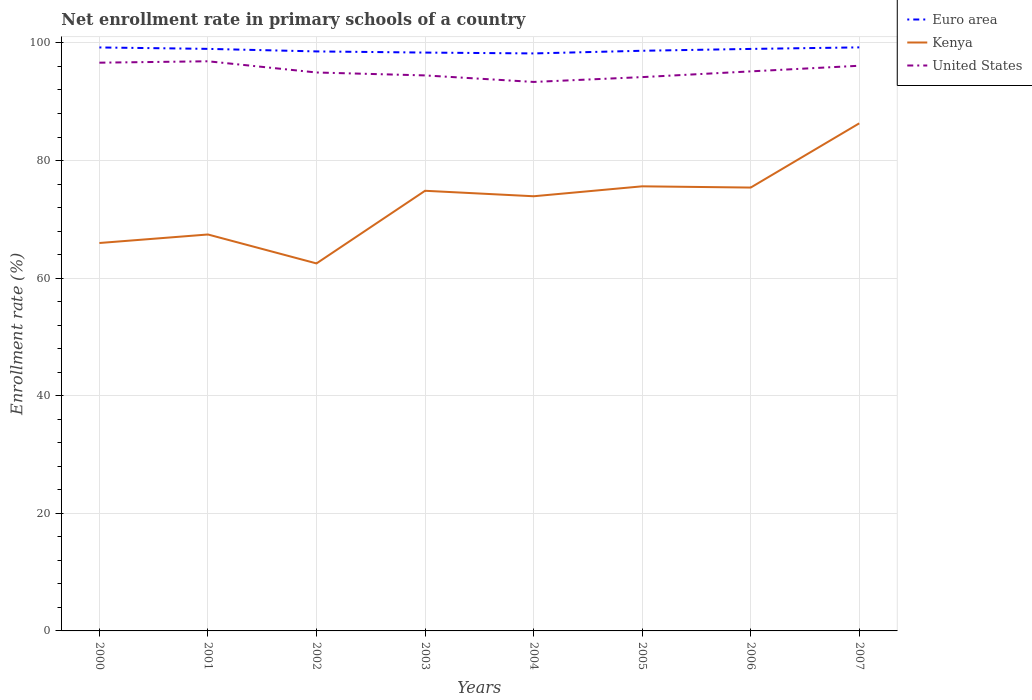How many different coloured lines are there?
Provide a succinct answer. 3. Does the line corresponding to Euro area intersect with the line corresponding to United States?
Ensure brevity in your answer.  No. Across all years, what is the maximum enrollment rate in primary schools in Euro area?
Give a very brief answer. 98.22. In which year was the enrollment rate in primary schools in United States maximum?
Give a very brief answer. 2004. What is the total enrollment rate in primary schools in United States in the graph?
Your answer should be very brief. 2.17. What is the difference between the highest and the second highest enrollment rate in primary schools in United States?
Provide a succinct answer. 3.51. Is the enrollment rate in primary schools in United States strictly greater than the enrollment rate in primary schools in Kenya over the years?
Give a very brief answer. No. How many years are there in the graph?
Keep it short and to the point. 8. What is the difference between two consecutive major ticks on the Y-axis?
Ensure brevity in your answer.  20. Does the graph contain grids?
Offer a terse response. Yes. Where does the legend appear in the graph?
Make the answer very short. Top right. What is the title of the graph?
Provide a short and direct response. Net enrollment rate in primary schools of a country. What is the label or title of the Y-axis?
Offer a very short reply. Enrollment rate (%). What is the Enrollment rate (%) of Euro area in 2000?
Your answer should be compact. 99.23. What is the Enrollment rate (%) of Kenya in 2000?
Your answer should be compact. 65.97. What is the Enrollment rate (%) of United States in 2000?
Your answer should be compact. 96.64. What is the Enrollment rate (%) in Euro area in 2001?
Give a very brief answer. 98.99. What is the Enrollment rate (%) in Kenya in 2001?
Provide a succinct answer. 67.42. What is the Enrollment rate (%) in United States in 2001?
Offer a terse response. 96.88. What is the Enrollment rate (%) in Euro area in 2002?
Give a very brief answer. 98.56. What is the Enrollment rate (%) in Kenya in 2002?
Your answer should be compact. 62.5. What is the Enrollment rate (%) of United States in 2002?
Your answer should be very brief. 94.97. What is the Enrollment rate (%) in Euro area in 2003?
Provide a short and direct response. 98.36. What is the Enrollment rate (%) in Kenya in 2003?
Ensure brevity in your answer.  74.85. What is the Enrollment rate (%) of United States in 2003?
Make the answer very short. 94.47. What is the Enrollment rate (%) of Euro area in 2004?
Ensure brevity in your answer.  98.22. What is the Enrollment rate (%) of Kenya in 2004?
Ensure brevity in your answer.  73.92. What is the Enrollment rate (%) in United States in 2004?
Ensure brevity in your answer.  93.36. What is the Enrollment rate (%) in Euro area in 2005?
Provide a succinct answer. 98.67. What is the Enrollment rate (%) of Kenya in 2005?
Your answer should be compact. 75.61. What is the Enrollment rate (%) in United States in 2005?
Provide a succinct answer. 94.19. What is the Enrollment rate (%) in Euro area in 2006?
Keep it short and to the point. 98.98. What is the Enrollment rate (%) in Kenya in 2006?
Give a very brief answer. 75.4. What is the Enrollment rate (%) in United States in 2006?
Provide a short and direct response. 95.16. What is the Enrollment rate (%) of Euro area in 2007?
Offer a terse response. 99.24. What is the Enrollment rate (%) in Kenya in 2007?
Offer a terse response. 86.33. What is the Enrollment rate (%) of United States in 2007?
Offer a terse response. 96.12. Across all years, what is the maximum Enrollment rate (%) in Euro area?
Keep it short and to the point. 99.24. Across all years, what is the maximum Enrollment rate (%) of Kenya?
Your response must be concise. 86.33. Across all years, what is the maximum Enrollment rate (%) of United States?
Your response must be concise. 96.88. Across all years, what is the minimum Enrollment rate (%) of Euro area?
Provide a short and direct response. 98.22. Across all years, what is the minimum Enrollment rate (%) in Kenya?
Keep it short and to the point. 62.5. Across all years, what is the minimum Enrollment rate (%) in United States?
Your answer should be compact. 93.36. What is the total Enrollment rate (%) of Euro area in the graph?
Keep it short and to the point. 790.24. What is the total Enrollment rate (%) of Kenya in the graph?
Your answer should be compact. 582.01. What is the total Enrollment rate (%) of United States in the graph?
Make the answer very short. 761.8. What is the difference between the Enrollment rate (%) in Euro area in 2000 and that in 2001?
Ensure brevity in your answer.  0.24. What is the difference between the Enrollment rate (%) of Kenya in 2000 and that in 2001?
Keep it short and to the point. -1.45. What is the difference between the Enrollment rate (%) of United States in 2000 and that in 2001?
Keep it short and to the point. -0.24. What is the difference between the Enrollment rate (%) of Euro area in 2000 and that in 2002?
Ensure brevity in your answer.  0.68. What is the difference between the Enrollment rate (%) of Kenya in 2000 and that in 2002?
Provide a short and direct response. 3.47. What is the difference between the Enrollment rate (%) of United States in 2000 and that in 2002?
Your answer should be very brief. 1.67. What is the difference between the Enrollment rate (%) in Euro area in 2000 and that in 2003?
Ensure brevity in your answer.  0.87. What is the difference between the Enrollment rate (%) of Kenya in 2000 and that in 2003?
Keep it short and to the point. -8.88. What is the difference between the Enrollment rate (%) of United States in 2000 and that in 2003?
Offer a terse response. 2.17. What is the difference between the Enrollment rate (%) in Euro area in 2000 and that in 2004?
Provide a short and direct response. 1.02. What is the difference between the Enrollment rate (%) in Kenya in 2000 and that in 2004?
Your response must be concise. -7.95. What is the difference between the Enrollment rate (%) in United States in 2000 and that in 2004?
Your answer should be very brief. 3.27. What is the difference between the Enrollment rate (%) in Euro area in 2000 and that in 2005?
Keep it short and to the point. 0.56. What is the difference between the Enrollment rate (%) in Kenya in 2000 and that in 2005?
Your answer should be very brief. -9.64. What is the difference between the Enrollment rate (%) in United States in 2000 and that in 2005?
Your answer should be very brief. 2.45. What is the difference between the Enrollment rate (%) in Euro area in 2000 and that in 2006?
Your response must be concise. 0.25. What is the difference between the Enrollment rate (%) in Kenya in 2000 and that in 2006?
Your answer should be compact. -9.43. What is the difference between the Enrollment rate (%) in United States in 2000 and that in 2006?
Offer a very short reply. 1.48. What is the difference between the Enrollment rate (%) in Euro area in 2000 and that in 2007?
Ensure brevity in your answer.  -0.01. What is the difference between the Enrollment rate (%) of Kenya in 2000 and that in 2007?
Provide a short and direct response. -20.35. What is the difference between the Enrollment rate (%) of United States in 2000 and that in 2007?
Make the answer very short. 0.52. What is the difference between the Enrollment rate (%) in Euro area in 2001 and that in 2002?
Provide a succinct answer. 0.43. What is the difference between the Enrollment rate (%) of Kenya in 2001 and that in 2002?
Provide a succinct answer. 4.92. What is the difference between the Enrollment rate (%) in United States in 2001 and that in 2002?
Your response must be concise. 1.91. What is the difference between the Enrollment rate (%) in Euro area in 2001 and that in 2003?
Provide a short and direct response. 0.63. What is the difference between the Enrollment rate (%) of Kenya in 2001 and that in 2003?
Your answer should be very brief. -7.43. What is the difference between the Enrollment rate (%) in United States in 2001 and that in 2003?
Provide a short and direct response. 2.4. What is the difference between the Enrollment rate (%) in Euro area in 2001 and that in 2004?
Keep it short and to the point. 0.77. What is the difference between the Enrollment rate (%) in Kenya in 2001 and that in 2004?
Ensure brevity in your answer.  -6.5. What is the difference between the Enrollment rate (%) in United States in 2001 and that in 2004?
Make the answer very short. 3.51. What is the difference between the Enrollment rate (%) of Euro area in 2001 and that in 2005?
Offer a terse response. 0.32. What is the difference between the Enrollment rate (%) in Kenya in 2001 and that in 2005?
Your answer should be compact. -8.19. What is the difference between the Enrollment rate (%) in United States in 2001 and that in 2005?
Offer a very short reply. 2.69. What is the difference between the Enrollment rate (%) of Euro area in 2001 and that in 2006?
Provide a succinct answer. 0.01. What is the difference between the Enrollment rate (%) of Kenya in 2001 and that in 2006?
Your answer should be very brief. -7.98. What is the difference between the Enrollment rate (%) in United States in 2001 and that in 2006?
Your answer should be very brief. 1.72. What is the difference between the Enrollment rate (%) of Euro area in 2001 and that in 2007?
Make the answer very short. -0.25. What is the difference between the Enrollment rate (%) of Kenya in 2001 and that in 2007?
Provide a short and direct response. -18.9. What is the difference between the Enrollment rate (%) in United States in 2001 and that in 2007?
Keep it short and to the point. 0.76. What is the difference between the Enrollment rate (%) of Euro area in 2002 and that in 2003?
Make the answer very short. 0.2. What is the difference between the Enrollment rate (%) of Kenya in 2002 and that in 2003?
Offer a very short reply. -12.35. What is the difference between the Enrollment rate (%) in United States in 2002 and that in 2003?
Your response must be concise. 0.5. What is the difference between the Enrollment rate (%) of Euro area in 2002 and that in 2004?
Provide a short and direct response. 0.34. What is the difference between the Enrollment rate (%) of Kenya in 2002 and that in 2004?
Your response must be concise. -11.42. What is the difference between the Enrollment rate (%) of United States in 2002 and that in 2004?
Offer a terse response. 1.61. What is the difference between the Enrollment rate (%) in Euro area in 2002 and that in 2005?
Keep it short and to the point. -0.11. What is the difference between the Enrollment rate (%) in Kenya in 2002 and that in 2005?
Offer a terse response. -13.11. What is the difference between the Enrollment rate (%) in United States in 2002 and that in 2005?
Your answer should be compact. 0.79. What is the difference between the Enrollment rate (%) of Euro area in 2002 and that in 2006?
Your response must be concise. -0.43. What is the difference between the Enrollment rate (%) of Kenya in 2002 and that in 2006?
Offer a very short reply. -12.9. What is the difference between the Enrollment rate (%) in United States in 2002 and that in 2006?
Your answer should be compact. -0.19. What is the difference between the Enrollment rate (%) in Euro area in 2002 and that in 2007?
Give a very brief answer. -0.69. What is the difference between the Enrollment rate (%) of Kenya in 2002 and that in 2007?
Keep it short and to the point. -23.82. What is the difference between the Enrollment rate (%) in United States in 2002 and that in 2007?
Ensure brevity in your answer.  -1.15. What is the difference between the Enrollment rate (%) of Euro area in 2003 and that in 2004?
Your answer should be very brief. 0.14. What is the difference between the Enrollment rate (%) in Kenya in 2003 and that in 2004?
Make the answer very short. 0.93. What is the difference between the Enrollment rate (%) in United States in 2003 and that in 2004?
Your answer should be compact. 1.11. What is the difference between the Enrollment rate (%) of Euro area in 2003 and that in 2005?
Offer a very short reply. -0.31. What is the difference between the Enrollment rate (%) of Kenya in 2003 and that in 2005?
Your response must be concise. -0.76. What is the difference between the Enrollment rate (%) in United States in 2003 and that in 2005?
Your answer should be very brief. 0.29. What is the difference between the Enrollment rate (%) in Euro area in 2003 and that in 2006?
Keep it short and to the point. -0.62. What is the difference between the Enrollment rate (%) of Kenya in 2003 and that in 2006?
Provide a succinct answer. -0.55. What is the difference between the Enrollment rate (%) in United States in 2003 and that in 2006?
Offer a terse response. -0.69. What is the difference between the Enrollment rate (%) of Euro area in 2003 and that in 2007?
Give a very brief answer. -0.88. What is the difference between the Enrollment rate (%) in Kenya in 2003 and that in 2007?
Give a very brief answer. -11.47. What is the difference between the Enrollment rate (%) of United States in 2003 and that in 2007?
Your answer should be compact. -1.64. What is the difference between the Enrollment rate (%) in Euro area in 2004 and that in 2005?
Your answer should be very brief. -0.45. What is the difference between the Enrollment rate (%) of Kenya in 2004 and that in 2005?
Offer a terse response. -1.69. What is the difference between the Enrollment rate (%) of United States in 2004 and that in 2005?
Offer a terse response. -0.82. What is the difference between the Enrollment rate (%) in Euro area in 2004 and that in 2006?
Ensure brevity in your answer.  -0.77. What is the difference between the Enrollment rate (%) of Kenya in 2004 and that in 2006?
Offer a very short reply. -1.48. What is the difference between the Enrollment rate (%) of United States in 2004 and that in 2006?
Provide a succinct answer. -1.8. What is the difference between the Enrollment rate (%) in Euro area in 2004 and that in 2007?
Your response must be concise. -1.03. What is the difference between the Enrollment rate (%) in Kenya in 2004 and that in 2007?
Your response must be concise. -12.4. What is the difference between the Enrollment rate (%) in United States in 2004 and that in 2007?
Ensure brevity in your answer.  -2.75. What is the difference between the Enrollment rate (%) of Euro area in 2005 and that in 2006?
Provide a short and direct response. -0.31. What is the difference between the Enrollment rate (%) in Kenya in 2005 and that in 2006?
Provide a succinct answer. 0.21. What is the difference between the Enrollment rate (%) of United States in 2005 and that in 2006?
Offer a terse response. -0.97. What is the difference between the Enrollment rate (%) in Euro area in 2005 and that in 2007?
Provide a short and direct response. -0.58. What is the difference between the Enrollment rate (%) in Kenya in 2005 and that in 2007?
Provide a succinct answer. -10.71. What is the difference between the Enrollment rate (%) of United States in 2005 and that in 2007?
Offer a terse response. -1.93. What is the difference between the Enrollment rate (%) in Euro area in 2006 and that in 2007?
Offer a terse response. -0.26. What is the difference between the Enrollment rate (%) in Kenya in 2006 and that in 2007?
Your answer should be very brief. -10.92. What is the difference between the Enrollment rate (%) of United States in 2006 and that in 2007?
Make the answer very short. -0.96. What is the difference between the Enrollment rate (%) in Euro area in 2000 and the Enrollment rate (%) in Kenya in 2001?
Keep it short and to the point. 31.81. What is the difference between the Enrollment rate (%) in Euro area in 2000 and the Enrollment rate (%) in United States in 2001?
Ensure brevity in your answer.  2.35. What is the difference between the Enrollment rate (%) in Kenya in 2000 and the Enrollment rate (%) in United States in 2001?
Offer a terse response. -30.91. What is the difference between the Enrollment rate (%) of Euro area in 2000 and the Enrollment rate (%) of Kenya in 2002?
Keep it short and to the point. 36.73. What is the difference between the Enrollment rate (%) of Euro area in 2000 and the Enrollment rate (%) of United States in 2002?
Offer a very short reply. 4.26. What is the difference between the Enrollment rate (%) in Kenya in 2000 and the Enrollment rate (%) in United States in 2002?
Offer a terse response. -29. What is the difference between the Enrollment rate (%) of Euro area in 2000 and the Enrollment rate (%) of Kenya in 2003?
Your answer should be very brief. 24.38. What is the difference between the Enrollment rate (%) of Euro area in 2000 and the Enrollment rate (%) of United States in 2003?
Ensure brevity in your answer.  4.76. What is the difference between the Enrollment rate (%) of Kenya in 2000 and the Enrollment rate (%) of United States in 2003?
Your answer should be very brief. -28.5. What is the difference between the Enrollment rate (%) of Euro area in 2000 and the Enrollment rate (%) of Kenya in 2004?
Provide a short and direct response. 25.31. What is the difference between the Enrollment rate (%) in Euro area in 2000 and the Enrollment rate (%) in United States in 2004?
Your answer should be compact. 5.87. What is the difference between the Enrollment rate (%) in Kenya in 2000 and the Enrollment rate (%) in United States in 2004?
Your answer should be very brief. -27.39. What is the difference between the Enrollment rate (%) in Euro area in 2000 and the Enrollment rate (%) in Kenya in 2005?
Offer a very short reply. 23.62. What is the difference between the Enrollment rate (%) of Euro area in 2000 and the Enrollment rate (%) of United States in 2005?
Offer a very short reply. 5.04. What is the difference between the Enrollment rate (%) in Kenya in 2000 and the Enrollment rate (%) in United States in 2005?
Provide a succinct answer. -28.21. What is the difference between the Enrollment rate (%) in Euro area in 2000 and the Enrollment rate (%) in Kenya in 2006?
Make the answer very short. 23.83. What is the difference between the Enrollment rate (%) of Euro area in 2000 and the Enrollment rate (%) of United States in 2006?
Offer a very short reply. 4.07. What is the difference between the Enrollment rate (%) in Kenya in 2000 and the Enrollment rate (%) in United States in 2006?
Your answer should be compact. -29.19. What is the difference between the Enrollment rate (%) in Euro area in 2000 and the Enrollment rate (%) in Kenya in 2007?
Your answer should be compact. 12.9. What is the difference between the Enrollment rate (%) of Euro area in 2000 and the Enrollment rate (%) of United States in 2007?
Your response must be concise. 3.11. What is the difference between the Enrollment rate (%) in Kenya in 2000 and the Enrollment rate (%) in United States in 2007?
Offer a very short reply. -30.15. What is the difference between the Enrollment rate (%) in Euro area in 2001 and the Enrollment rate (%) in Kenya in 2002?
Give a very brief answer. 36.49. What is the difference between the Enrollment rate (%) of Euro area in 2001 and the Enrollment rate (%) of United States in 2002?
Ensure brevity in your answer.  4.02. What is the difference between the Enrollment rate (%) of Kenya in 2001 and the Enrollment rate (%) of United States in 2002?
Make the answer very short. -27.55. What is the difference between the Enrollment rate (%) in Euro area in 2001 and the Enrollment rate (%) in Kenya in 2003?
Give a very brief answer. 24.14. What is the difference between the Enrollment rate (%) in Euro area in 2001 and the Enrollment rate (%) in United States in 2003?
Ensure brevity in your answer.  4.52. What is the difference between the Enrollment rate (%) of Kenya in 2001 and the Enrollment rate (%) of United States in 2003?
Provide a short and direct response. -27.05. What is the difference between the Enrollment rate (%) of Euro area in 2001 and the Enrollment rate (%) of Kenya in 2004?
Offer a terse response. 25.07. What is the difference between the Enrollment rate (%) of Euro area in 2001 and the Enrollment rate (%) of United States in 2004?
Ensure brevity in your answer.  5.62. What is the difference between the Enrollment rate (%) in Kenya in 2001 and the Enrollment rate (%) in United States in 2004?
Give a very brief answer. -25.94. What is the difference between the Enrollment rate (%) in Euro area in 2001 and the Enrollment rate (%) in Kenya in 2005?
Your answer should be very brief. 23.38. What is the difference between the Enrollment rate (%) in Euro area in 2001 and the Enrollment rate (%) in United States in 2005?
Ensure brevity in your answer.  4.8. What is the difference between the Enrollment rate (%) in Kenya in 2001 and the Enrollment rate (%) in United States in 2005?
Offer a terse response. -26.76. What is the difference between the Enrollment rate (%) of Euro area in 2001 and the Enrollment rate (%) of Kenya in 2006?
Keep it short and to the point. 23.59. What is the difference between the Enrollment rate (%) in Euro area in 2001 and the Enrollment rate (%) in United States in 2006?
Your answer should be very brief. 3.83. What is the difference between the Enrollment rate (%) of Kenya in 2001 and the Enrollment rate (%) of United States in 2006?
Keep it short and to the point. -27.74. What is the difference between the Enrollment rate (%) in Euro area in 2001 and the Enrollment rate (%) in Kenya in 2007?
Your answer should be compact. 12.66. What is the difference between the Enrollment rate (%) of Euro area in 2001 and the Enrollment rate (%) of United States in 2007?
Your response must be concise. 2.87. What is the difference between the Enrollment rate (%) of Kenya in 2001 and the Enrollment rate (%) of United States in 2007?
Give a very brief answer. -28.7. What is the difference between the Enrollment rate (%) in Euro area in 2002 and the Enrollment rate (%) in Kenya in 2003?
Your answer should be very brief. 23.7. What is the difference between the Enrollment rate (%) of Euro area in 2002 and the Enrollment rate (%) of United States in 2003?
Ensure brevity in your answer.  4.08. What is the difference between the Enrollment rate (%) of Kenya in 2002 and the Enrollment rate (%) of United States in 2003?
Make the answer very short. -31.97. What is the difference between the Enrollment rate (%) in Euro area in 2002 and the Enrollment rate (%) in Kenya in 2004?
Your answer should be compact. 24.63. What is the difference between the Enrollment rate (%) of Euro area in 2002 and the Enrollment rate (%) of United States in 2004?
Your response must be concise. 5.19. What is the difference between the Enrollment rate (%) in Kenya in 2002 and the Enrollment rate (%) in United States in 2004?
Ensure brevity in your answer.  -30.86. What is the difference between the Enrollment rate (%) in Euro area in 2002 and the Enrollment rate (%) in Kenya in 2005?
Ensure brevity in your answer.  22.94. What is the difference between the Enrollment rate (%) in Euro area in 2002 and the Enrollment rate (%) in United States in 2005?
Keep it short and to the point. 4.37. What is the difference between the Enrollment rate (%) of Kenya in 2002 and the Enrollment rate (%) of United States in 2005?
Offer a terse response. -31.69. What is the difference between the Enrollment rate (%) in Euro area in 2002 and the Enrollment rate (%) in Kenya in 2006?
Offer a terse response. 23.15. What is the difference between the Enrollment rate (%) of Euro area in 2002 and the Enrollment rate (%) of United States in 2006?
Ensure brevity in your answer.  3.39. What is the difference between the Enrollment rate (%) of Kenya in 2002 and the Enrollment rate (%) of United States in 2006?
Provide a succinct answer. -32.66. What is the difference between the Enrollment rate (%) of Euro area in 2002 and the Enrollment rate (%) of Kenya in 2007?
Give a very brief answer. 12.23. What is the difference between the Enrollment rate (%) in Euro area in 2002 and the Enrollment rate (%) in United States in 2007?
Offer a very short reply. 2.44. What is the difference between the Enrollment rate (%) in Kenya in 2002 and the Enrollment rate (%) in United States in 2007?
Keep it short and to the point. -33.62. What is the difference between the Enrollment rate (%) in Euro area in 2003 and the Enrollment rate (%) in Kenya in 2004?
Your answer should be very brief. 24.44. What is the difference between the Enrollment rate (%) in Euro area in 2003 and the Enrollment rate (%) in United States in 2004?
Offer a terse response. 4.99. What is the difference between the Enrollment rate (%) in Kenya in 2003 and the Enrollment rate (%) in United States in 2004?
Make the answer very short. -18.51. What is the difference between the Enrollment rate (%) in Euro area in 2003 and the Enrollment rate (%) in Kenya in 2005?
Your answer should be compact. 22.75. What is the difference between the Enrollment rate (%) in Euro area in 2003 and the Enrollment rate (%) in United States in 2005?
Provide a short and direct response. 4.17. What is the difference between the Enrollment rate (%) in Kenya in 2003 and the Enrollment rate (%) in United States in 2005?
Offer a terse response. -19.33. What is the difference between the Enrollment rate (%) in Euro area in 2003 and the Enrollment rate (%) in Kenya in 2006?
Provide a short and direct response. 22.96. What is the difference between the Enrollment rate (%) of Euro area in 2003 and the Enrollment rate (%) of United States in 2006?
Give a very brief answer. 3.2. What is the difference between the Enrollment rate (%) in Kenya in 2003 and the Enrollment rate (%) in United States in 2006?
Offer a terse response. -20.31. What is the difference between the Enrollment rate (%) in Euro area in 2003 and the Enrollment rate (%) in Kenya in 2007?
Ensure brevity in your answer.  12.03. What is the difference between the Enrollment rate (%) of Euro area in 2003 and the Enrollment rate (%) of United States in 2007?
Offer a very short reply. 2.24. What is the difference between the Enrollment rate (%) in Kenya in 2003 and the Enrollment rate (%) in United States in 2007?
Your answer should be very brief. -21.27. What is the difference between the Enrollment rate (%) of Euro area in 2004 and the Enrollment rate (%) of Kenya in 2005?
Ensure brevity in your answer.  22.6. What is the difference between the Enrollment rate (%) of Euro area in 2004 and the Enrollment rate (%) of United States in 2005?
Provide a short and direct response. 4.03. What is the difference between the Enrollment rate (%) in Kenya in 2004 and the Enrollment rate (%) in United States in 2005?
Ensure brevity in your answer.  -20.26. What is the difference between the Enrollment rate (%) in Euro area in 2004 and the Enrollment rate (%) in Kenya in 2006?
Provide a short and direct response. 22.81. What is the difference between the Enrollment rate (%) in Euro area in 2004 and the Enrollment rate (%) in United States in 2006?
Provide a short and direct response. 3.05. What is the difference between the Enrollment rate (%) of Kenya in 2004 and the Enrollment rate (%) of United States in 2006?
Give a very brief answer. -21.24. What is the difference between the Enrollment rate (%) of Euro area in 2004 and the Enrollment rate (%) of Kenya in 2007?
Your answer should be compact. 11.89. What is the difference between the Enrollment rate (%) in Euro area in 2004 and the Enrollment rate (%) in United States in 2007?
Provide a short and direct response. 2.1. What is the difference between the Enrollment rate (%) in Kenya in 2004 and the Enrollment rate (%) in United States in 2007?
Your response must be concise. -22.2. What is the difference between the Enrollment rate (%) of Euro area in 2005 and the Enrollment rate (%) of Kenya in 2006?
Provide a succinct answer. 23.27. What is the difference between the Enrollment rate (%) of Euro area in 2005 and the Enrollment rate (%) of United States in 2006?
Ensure brevity in your answer.  3.51. What is the difference between the Enrollment rate (%) in Kenya in 2005 and the Enrollment rate (%) in United States in 2006?
Ensure brevity in your answer.  -19.55. What is the difference between the Enrollment rate (%) in Euro area in 2005 and the Enrollment rate (%) in Kenya in 2007?
Provide a short and direct response. 12.34. What is the difference between the Enrollment rate (%) in Euro area in 2005 and the Enrollment rate (%) in United States in 2007?
Ensure brevity in your answer.  2.55. What is the difference between the Enrollment rate (%) of Kenya in 2005 and the Enrollment rate (%) of United States in 2007?
Give a very brief answer. -20.51. What is the difference between the Enrollment rate (%) in Euro area in 2006 and the Enrollment rate (%) in Kenya in 2007?
Provide a short and direct response. 12.66. What is the difference between the Enrollment rate (%) of Euro area in 2006 and the Enrollment rate (%) of United States in 2007?
Make the answer very short. 2.86. What is the difference between the Enrollment rate (%) of Kenya in 2006 and the Enrollment rate (%) of United States in 2007?
Keep it short and to the point. -20.72. What is the average Enrollment rate (%) of Euro area per year?
Make the answer very short. 98.78. What is the average Enrollment rate (%) in Kenya per year?
Your response must be concise. 72.75. What is the average Enrollment rate (%) in United States per year?
Your answer should be compact. 95.22. In the year 2000, what is the difference between the Enrollment rate (%) of Euro area and Enrollment rate (%) of Kenya?
Provide a short and direct response. 33.26. In the year 2000, what is the difference between the Enrollment rate (%) in Euro area and Enrollment rate (%) in United States?
Your response must be concise. 2.59. In the year 2000, what is the difference between the Enrollment rate (%) of Kenya and Enrollment rate (%) of United States?
Offer a very short reply. -30.67. In the year 2001, what is the difference between the Enrollment rate (%) of Euro area and Enrollment rate (%) of Kenya?
Provide a short and direct response. 31.57. In the year 2001, what is the difference between the Enrollment rate (%) in Euro area and Enrollment rate (%) in United States?
Offer a terse response. 2.11. In the year 2001, what is the difference between the Enrollment rate (%) in Kenya and Enrollment rate (%) in United States?
Provide a short and direct response. -29.46. In the year 2002, what is the difference between the Enrollment rate (%) of Euro area and Enrollment rate (%) of Kenya?
Ensure brevity in your answer.  36.05. In the year 2002, what is the difference between the Enrollment rate (%) of Euro area and Enrollment rate (%) of United States?
Keep it short and to the point. 3.58. In the year 2002, what is the difference between the Enrollment rate (%) of Kenya and Enrollment rate (%) of United States?
Give a very brief answer. -32.47. In the year 2003, what is the difference between the Enrollment rate (%) of Euro area and Enrollment rate (%) of Kenya?
Your answer should be very brief. 23.51. In the year 2003, what is the difference between the Enrollment rate (%) of Euro area and Enrollment rate (%) of United States?
Your answer should be very brief. 3.88. In the year 2003, what is the difference between the Enrollment rate (%) in Kenya and Enrollment rate (%) in United States?
Make the answer very short. -19.62. In the year 2004, what is the difference between the Enrollment rate (%) in Euro area and Enrollment rate (%) in Kenya?
Keep it short and to the point. 24.29. In the year 2004, what is the difference between the Enrollment rate (%) in Euro area and Enrollment rate (%) in United States?
Provide a short and direct response. 4.85. In the year 2004, what is the difference between the Enrollment rate (%) in Kenya and Enrollment rate (%) in United States?
Offer a terse response. -19.44. In the year 2005, what is the difference between the Enrollment rate (%) in Euro area and Enrollment rate (%) in Kenya?
Your response must be concise. 23.05. In the year 2005, what is the difference between the Enrollment rate (%) of Euro area and Enrollment rate (%) of United States?
Ensure brevity in your answer.  4.48. In the year 2005, what is the difference between the Enrollment rate (%) of Kenya and Enrollment rate (%) of United States?
Offer a very short reply. -18.57. In the year 2006, what is the difference between the Enrollment rate (%) in Euro area and Enrollment rate (%) in Kenya?
Your answer should be compact. 23.58. In the year 2006, what is the difference between the Enrollment rate (%) in Euro area and Enrollment rate (%) in United States?
Provide a short and direct response. 3.82. In the year 2006, what is the difference between the Enrollment rate (%) in Kenya and Enrollment rate (%) in United States?
Give a very brief answer. -19.76. In the year 2007, what is the difference between the Enrollment rate (%) in Euro area and Enrollment rate (%) in Kenya?
Give a very brief answer. 12.92. In the year 2007, what is the difference between the Enrollment rate (%) in Euro area and Enrollment rate (%) in United States?
Give a very brief answer. 3.12. In the year 2007, what is the difference between the Enrollment rate (%) of Kenya and Enrollment rate (%) of United States?
Offer a terse response. -9.79. What is the ratio of the Enrollment rate (%) of Euro area in 2000 to that in 2001?
Ensure brevity in your answer.  1. What is the ratio of the Enrollment rate (%) of Kenya in 2000 to that in 2001?
Ensure brevity in your answer.  0.98. What is the ratio of the Enrollment rate (%) of United States in 2000 to that in 2001?
Your response must be concise. 1. What is the ratio of the Enrollment rate (%) in Euro area in 2000 to that in 2002?
Your answer should be very brief. 1.01. What is the ratio of the Enrollment rate (%) of Kenya in 2000 to that in 2002?
Offer a terse response. 1.06. What is the ratio of the Enrollment rate (%) of United States in 2000 to that in 2002?
Provide a short and direct response. 1.02. What is the ratio of the Enrollment rate (%) of Euro area in 2000 to that in 2003?
Provide a short and direct response. 1.01. What is the ratio of the Enrollment rate (%) of Kenya in 2000 to that in 2003?
Give a very brief answer. 0.88. What is the ratio of the Enrollment rate (%) of United States in 2000 to that in 2003?
Provide a short and direct response. 1.02. What is the ratio of the Enrollment rate (%) in Euro area in 2000 to that in 2004?
Your answer should be very brief. 1.01. What is the ratio of the Enrollment rate (%) in Kenya in 2000 to that in 2004?
Provide a succinct answer. 0.89. What is the ratio of the Enrollment rate (%) of United States in 2000 to that in 2004?
Offer a terse response. 1.04. What is the ratio of the Enrollment rate (%) in Kenya in 2000 to that in 2005?
Ensure brevity in your answer.  0.87. What is the ratio of the Enrollment rate (%) in United States in 2000 to that in 2005?
Your answer should be very brief. 1.03. What is the ratio of the Enrollment rate (%) in Kenya in 2000 to that in 2006?
Give a very brief answer. 0.88. What is the ratio of the Enrollment rate (%) in United States in 2000 to that in 2006?
Your response must be concise. 1.02. What is the ratio of the Enrollment rate (%) of Kenya in 2000 to that in 2007?
Your answer should be compact. 0.76. What is the ratio of the Enrollment rate (%) in United States in 2000 to that in 2007?
Ensure brevity in your answer.  1.01. What is the ratio of the Enrollment rate (%) of Euro area in 2001 to that in 2002?
Ensure brevity in your answer.  1. What is the ratio of the Enrollment rate (%) in Kenya in 2001 to that in 2002?
Your answer should be very brief. 1.08. What is the ratio of the Enrollment rate (%) in United States in 2001 to that in 2002?
Your response must be concise. 1.02. What is the ratio of the Enrollment rate (%) of Euro area in 2001 to that in 2003?
Make the answer very short. 1.01. What is the ratio of the Enrollment rate (%) in Kenya in 2001 to that in 2003?
Offer a very short reply. 0.9. What is the ratio of the Enrollment rate (%) in United States in 2001 to that in 2003?
Offer a terse response. 1.03. What is the ratio of the Enrollment rate (%) in Euro area in 2001 to that in 2004?
Offer a very short reply. 1.01. What is the ratio of the Enrollment rate (%) in Kenya in 2001 to that in 2004?
Give a very brief answer. 0.91. What is the ratio of the Enrollment rate (%) in United States in 2001 to that in 2004?
Offer a terse response. 1.04. What is the ratio of the Enrollment rate (%) of Kenya in 2001 to that in 2005?
Your answer should be compact. 0.89. What is the ratio of the Enrollment rate (%) of United States in 2001 to that in 2005?
Make the answer very short. 1.03. What is the ratio of the Enrollment rate (%) in Euro area in 2001 to that in 2006?
Your response must be concise. 1. What is the ratio of the Enrollment rate (%) of Kenya in 2001 to that in 2006?
Offer a terse response. 0.89. What is the ratio of the Enrollment rate (%) in United States in 2001 to that in 2006?
Offer a terse response. 1.02. What is the ratio of the Enrollment rate (%) in Kenya in 2001 to that in 2007?
Your answer should be compact. 0.78. What is the ratio of the Enrollment rate (%) in United States in 2001 to that in 2007?
Provide a short and direct response. 1.01. What is the ratio of the Enrollment rate (%) in Euro area in 2002 to that in 2003?
Provide a succinct answer. 1. What is the ratio of the Enrollment rate (%) of Kenya in 2002 to that in 2003?
Your answer should be compact. 0.83. What is the ratio of the Enrollment rate (%) of Euro area in 2002 to that in 2004?
Your answer should be very brief. 1. What is the ratio of the Enrollment rate (%) in Kenya in 2002 to that in 2004?
Your response must be concise. 0.85. What is the ratio of the Enrollment rate (%) of United States in 2002 to that in 2004?
Your answer should be compact. 1.02. What is the ratio of the Enrollment rate (%) of Kenya in 2002 to that in 2005?
Provide a short and direct response. 0.83. What is the ratio of the Enrollment rate (%) of United States in 2002 to that in 2005?
Your answer should be compact. 1.01. What is the ratio of the Enrollment rate (%) in Euro area in 2002 to that in 2006?
Ensure brevity in your answer.  1. What is the ratio of the Enrollment rate (%) of Kenya in 2002 to that in 2006?
Provide a short and direct response. 0.83. What is the ratio of the Enrollment rate (%) of United States in 2002 to that in 2006?
Provide a short and direct response. 1. What is the ratio of the Enrollment rate (%) of Kenya in 2002 to that in 2007?
Offer a very short reply. 0.72. What is the ratio of the Enrollment rate (%) in Euro area in 2003 to that in 2004?
Keep it short and to the point. 1. What is the ratio of the Enrollment rate (%) in Kenya in 2003 to that in 2004?
Ensure brevity in your answer.  1.01. What is the ratio of the Enrollment rate (%) of United States in 2003 to that in 2004?
Your answer should be compact. 1.01. What is the ratio of the Enrollment rate (%) in Euro area in 2003 to that in 2005?
Offer a terse response. 1. What is the ratio of the Enrollment rate (%) in Kenya in 2003 to that in 2005?
Your response must be concise. 0.99. What is the ratio of the Enrollment rate (%) in United States in 2003 to that in 2005?
Make the answer very short. 1. What is the ratio of the Enrollment rate (%) of Kenya in 2003 to that in 2006?
Ensure brevity in your answer.  0.99. What is the ratio of the Enrollment rate (%) in United States in 2003 to that in 2006?
Provide a succinct answer. 0.99. What is the ratio of the Enrollment rate (%) of Euro area in 2003 to that in 2007?
Offer a very short reply. 0.99. What is the ratio of the Enrollment rate (%) in Kenya in 2003 to that in 2007?
Provide a short and direct response. 0.87. What is the ratio of the Enrollment rate (%) of United States in 2003 to that in 2007?
Make the answer very short. 0.98. What is the ratio of the Enrollment rate (%) in Kenya in 2004 to that in 2005?
Keep it short and to the point. 0.98. What is the ratio of the Enrollment rate (%) in Kenya in 2004 to that in 2006?
Keep it short and to the point. 0.98. What is the ratio of the Enrollment rate (%) of United States in 2004 to that in 2006?
Ensure brevity in your answer.  0.98. What is the ratio of the Enrollment rate (%) of Kenya in 2004 to that in 2007?
Offer a very short reply. 0.86. What is the ratio of the Enrollment rate (%) of United States in 2004 to that in 2007?
Your response must be concise. 0.97. What is the ratio of the Enrollment rate (%) in Euro area in 2005 to that in 2007?
Your response must be concise. 0.99. What is the ratio of the Enrollment rate (%) in Kenya in 2005 to that in 2007?
Ensure brevity in your answer.  0.88. What is the ratio of the Enrollment rate (%) of United States in 2005 to that in 2007?
Your answer should be very brief. 0.98. What is the ratio of the Enrollment rate (%) in Kenya in 2006 to that in 2007?
Your answer should be very brief. 0.87. What is the ratio of the Enrollment rate (%) in United States in 2006 to that in 2007?
Your answer should be very brief. 0.99. What is the difference between the highest and the second highest Enrollment rate (%) in Euro area?
Your answer should be compact. 0.01. What is the difference between the highest and the second highest Enrollment rate (%) in Kenya?
Provide a short and direct response. 10.71. What is the difference between the highest and the second highest Enrollment rate (%) of United States?
Give a very brief answer. 0.24. What is the difference between the highest and the lowest Enrollment rate (%) in Euro area?
Your answer should be compact. 1.03. What is the difference between the highest and the lowest Enrollment rate (%) in Kenya?
Make the answer very short. 23.82. What is the difference between the highest and the lowest Enrollment rate (%) of United States?
Your response must be concise. 3.51. 